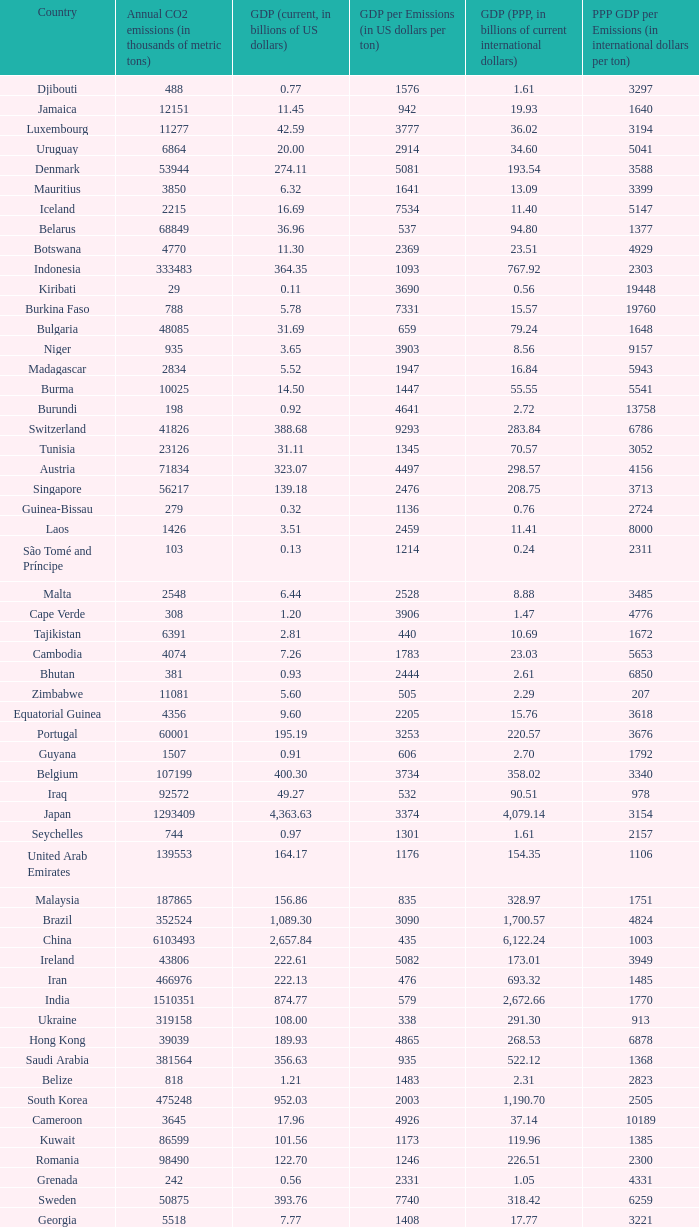When the gdp per emissions (in us dollars per ton) is 3903, what is the maximum annual co2 emissions (in thousands of metric tons)? 935.0. 